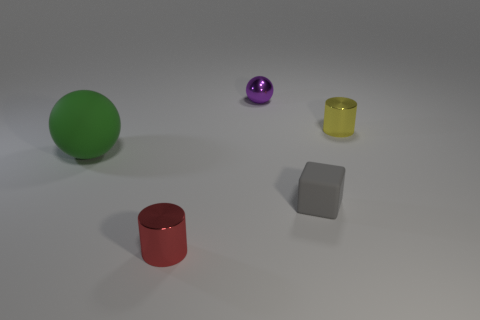Add 1 purple metal things. How many objects exist? 6 Subtract all cylinders. How many objects are left? 3 Add 5 red things. How many red things are left? 6 Add 5 tiny metal objects. How many tiny metal objects exist? 8 Subtract 0 brown cubes. How many objects are left? 5 Subtract all small cylinders. Subtract all metallic balls. How many objects are left? 2 